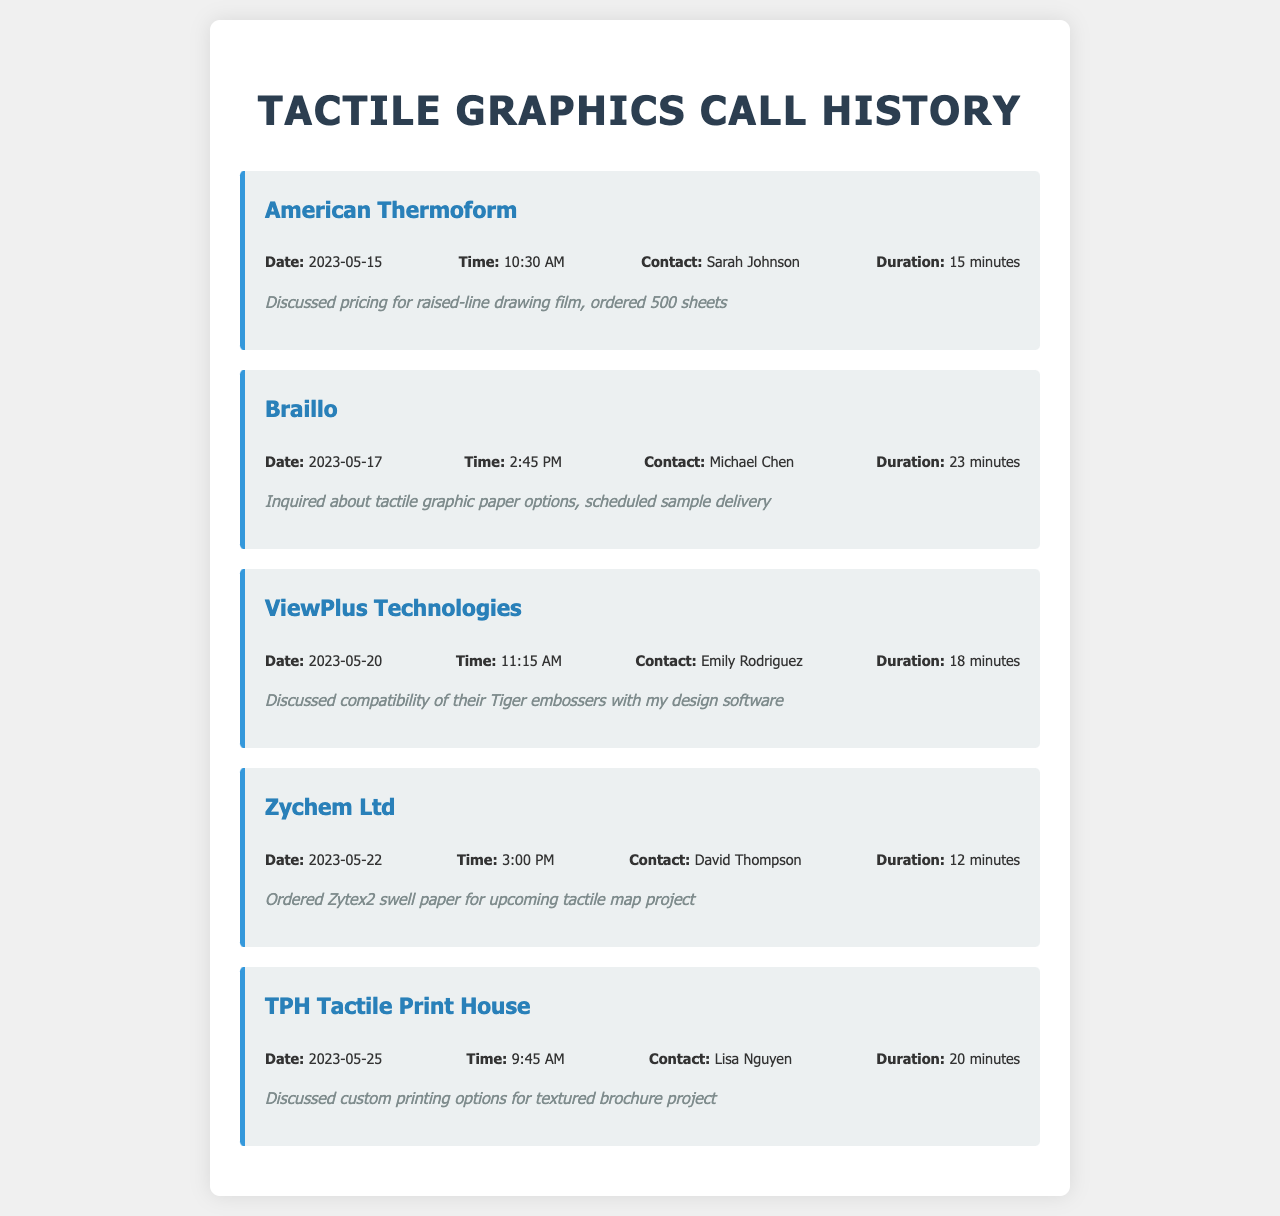What company was contacted on May 15, 2023? The call record for May 15, 2023, identifies American Thermoform as the contacted company.
Answer: American Thermoform Who was the contact person at Braillo? The call record for Braillo indicates Michael Chen as the contact person.
Answer: Michael Chen What was the duration of the call with TPH Tactile Print House? The call record shows that the duration of the call with TPH Tactile Print House was 20 minutes.
Answer: 20 minutes When was the sample delivery scheduled during the call with Braillo? The notes for the call with Braillo mention that a sample delivery was scheduled but do not specify the date.
Answer: Not specified What product was ordered from Zychem Ltd? The notes indicate that Zytex2 swell paper was ordered from Zychem Ltd for a tactile map project.
Answer: Zytex2 swell paper Which company discussed custom printing options? TPH Tactile Print House is the company that discussed custom printing options.
Answer: TPH Tactile Print House What is the total number of sheets ordered from American Thermoform? According to the notes for the call with American Thermoform, 500 sheets were ordered.
Answer: 500 sheets How many minutes was the call with ViewPlus Technologies? The duration for the call with ViewPlus Technologies was 18 minutes as stated in the call details.
Answer: 18 minutes What day of the week was the call to Zychem Ltd made? The call to Zychem Ltd was made on a Tuesday, as shown by the date in the call record.
Answer: Tuesday 